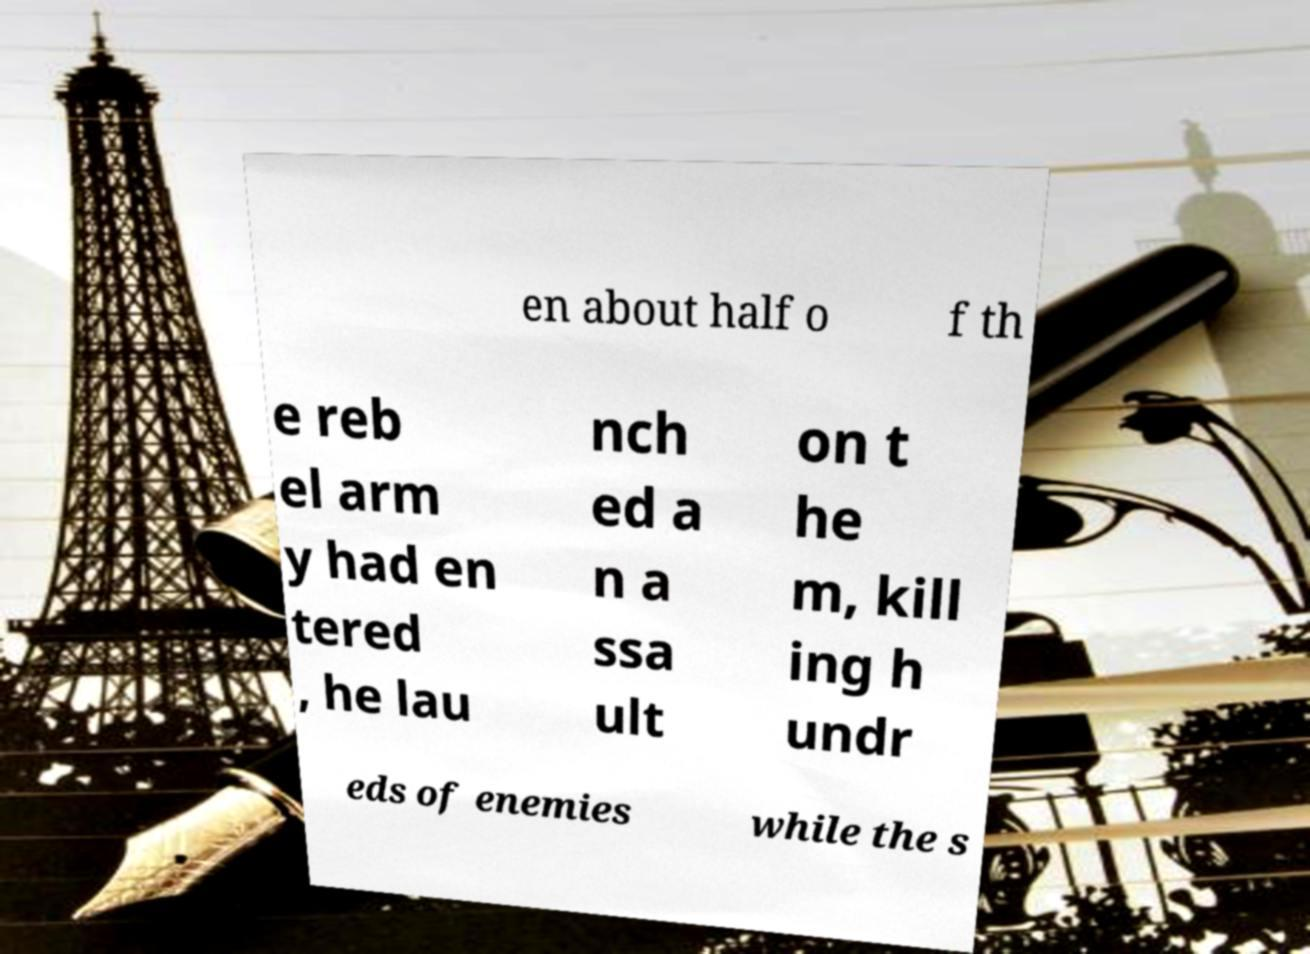What messages or text are displayed in this image? I need them in a readable, typed format. en about half o f th e reb el arm y had en tered , he lau nch ed a n a ssa ult on t he m, kill ing h undr eds of enemies while the s 